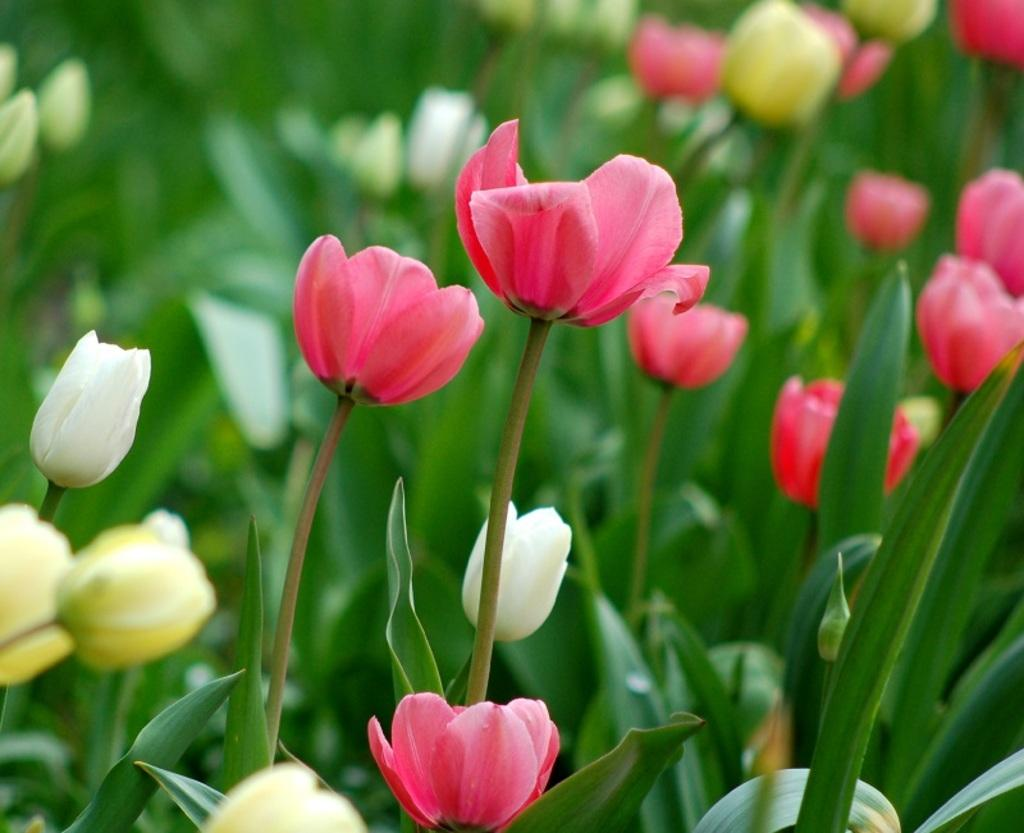What colors are the flowers on the plants in the image? There are pink, white, and yellow flowers on the plants in the image. Can you describe the variety of flowers on the plants? The plants have pink, white, and yellow flowers. What type of crime is being committed in the image? There is no crime present in the image; it features plants with flowers. Can you describe the driving skills of the yellow flowers in the image? There is no driving or any vehicles present in the image, so it is not possible to assess the driving skills of the yellow flowers. 